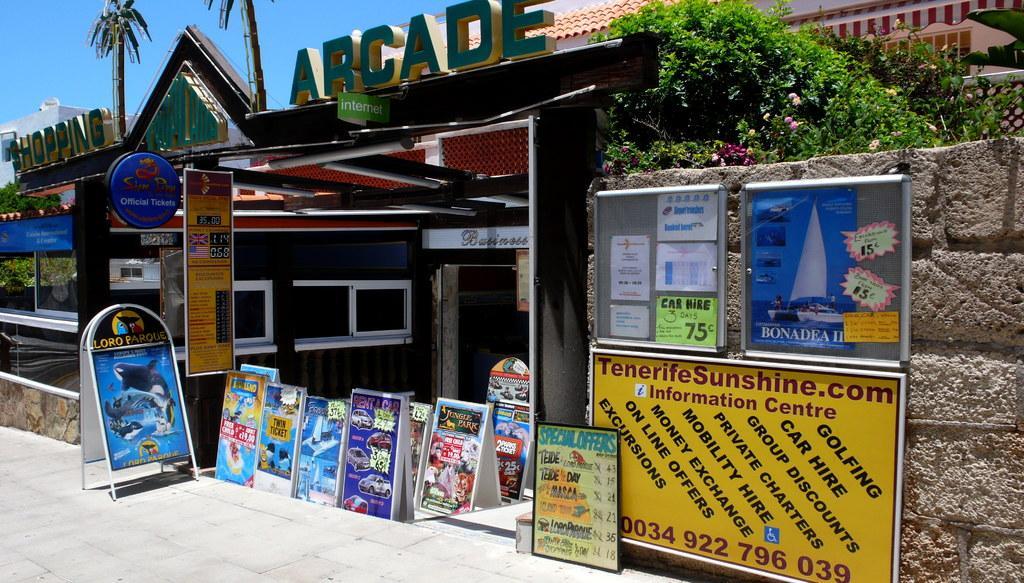Describe this image in one or two sentences. In this image I can see number of boards, wall, trees, building and the sky. I can see something is written on these boards and over there I can see one more building. 